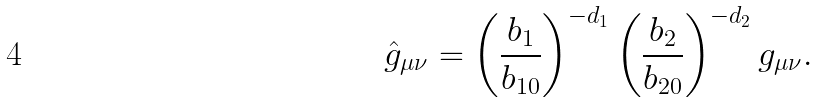Convert formula to latex. <formula><loc_0><loc_0><loc_500><loc_500>\hat { g } _ { \mu \nu } = \left ( \frac { b _ { 1 } } { b _ { 1 0 } } \right ) ^ { - d _ { 1 } } \left ( \frac { b _ { 2 } } { b _ { 2 0 } } \right ) ^ { - d _ { 2 } } g _ { \mu \nu } .</formula> 